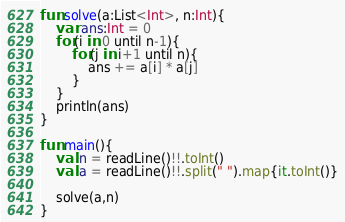Convert code to text. <code><loc_0><loc_0><loc_500><loc_500><_Kotlin_>fun solve(a:List<Int>, n:Int){
    var ans:Int = 0
    for(i in 0 until n-1){
        for(j in i+1 until n){
            ans += a[i] * a[j]
        }
    }
    println(ans)
}

fun main(){
    val n = readLine()!!.toInt()
    val a = readLine()!!.split(" ").map{it.toInt()}

    solve(a,n)
}</code> 